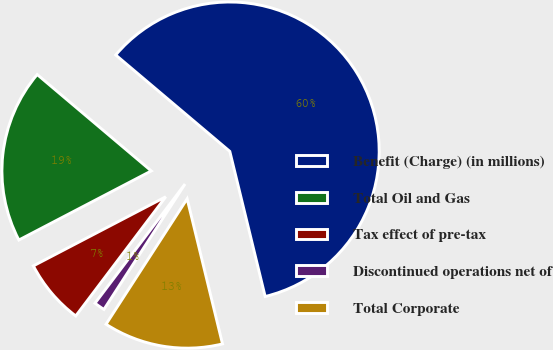<chart> <loc_0><loc_0><loc_500><loc_500><pie_chart><fcel>Benefit (Charge) (in millions)<fcel>Total Oil and Gas<fcel>Tax effect of pre-tax<fcel>Discontinued operations net of<fcel>Total Corporate<nl><fcel>60.03%<fcel>18.82%<fcel>7.05%<fcel>1.16%<fcel>12.94%<nl></chart> 